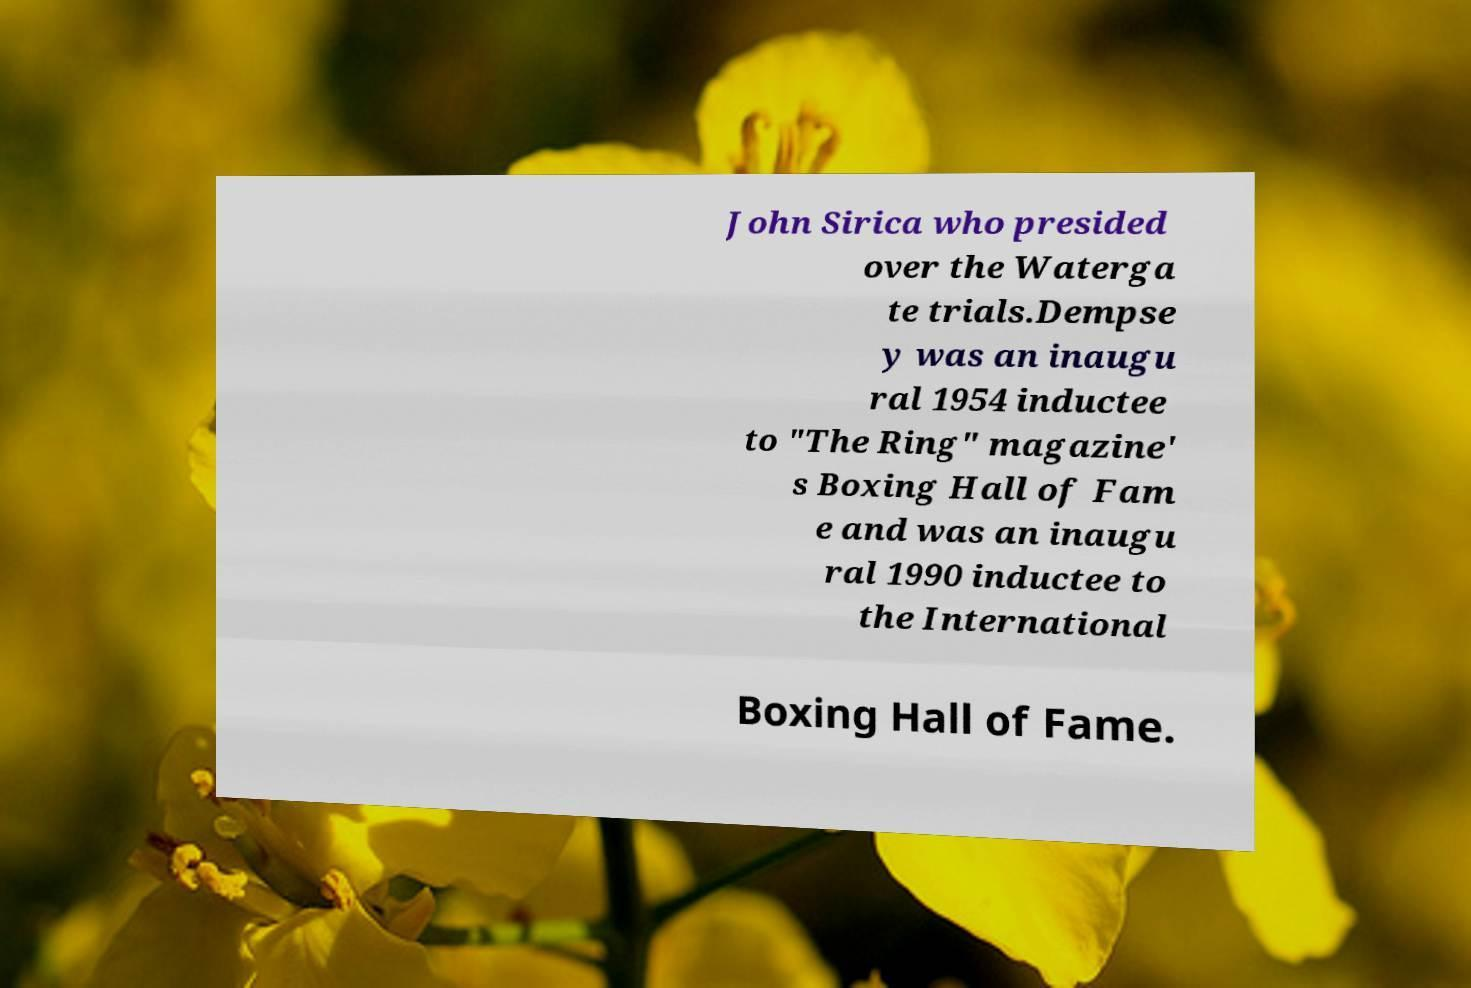Could you extract and type out the text from this image? John Sirica who presided over the Waterga te trials.Dempse y was an inaugu ral 1954 inductee to "The Ring" magazine' s Boxing Hall of Fam e and was an inaugu ral 1990 inductee to the International Boxing Hall of Fame. 